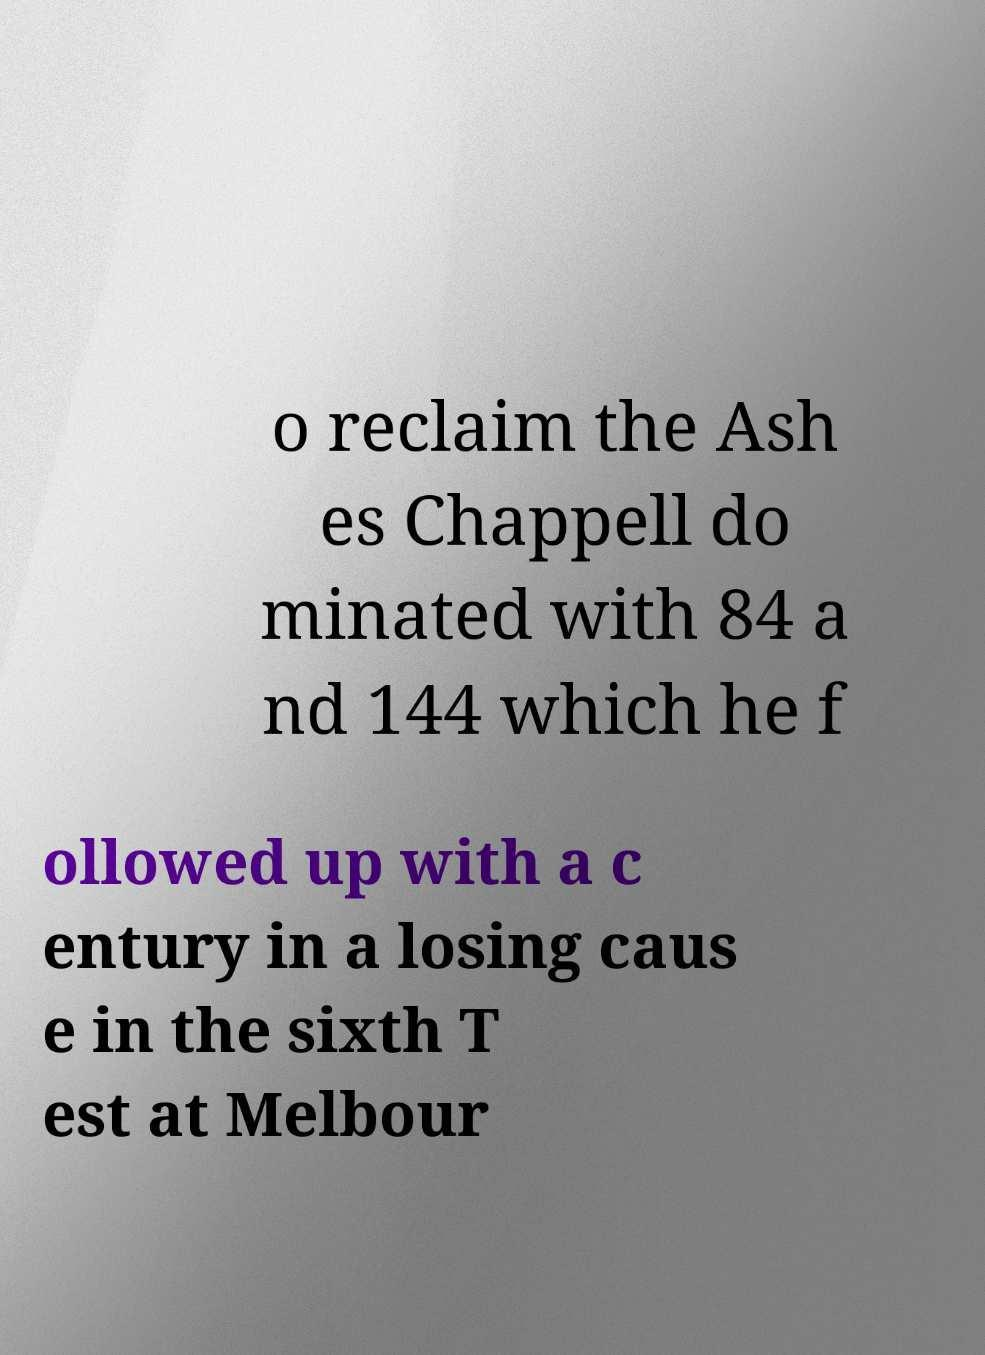Could you extract and type out the text from this image? o reclaim the Ash es Chappell do minated with 84 a nd 144 which he f ollowed up with a c entury in a losing caus e in the sixth T est at Melbour 